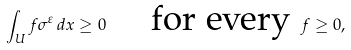Convert formula to latex. <formula><loc_0><loc_0><loc_500><loc_500>\int _ { U } f \sigma ^ { \varepsilon } \, d x \geq 0 \quad \text { for every } f \geq 0 ,</formula> 